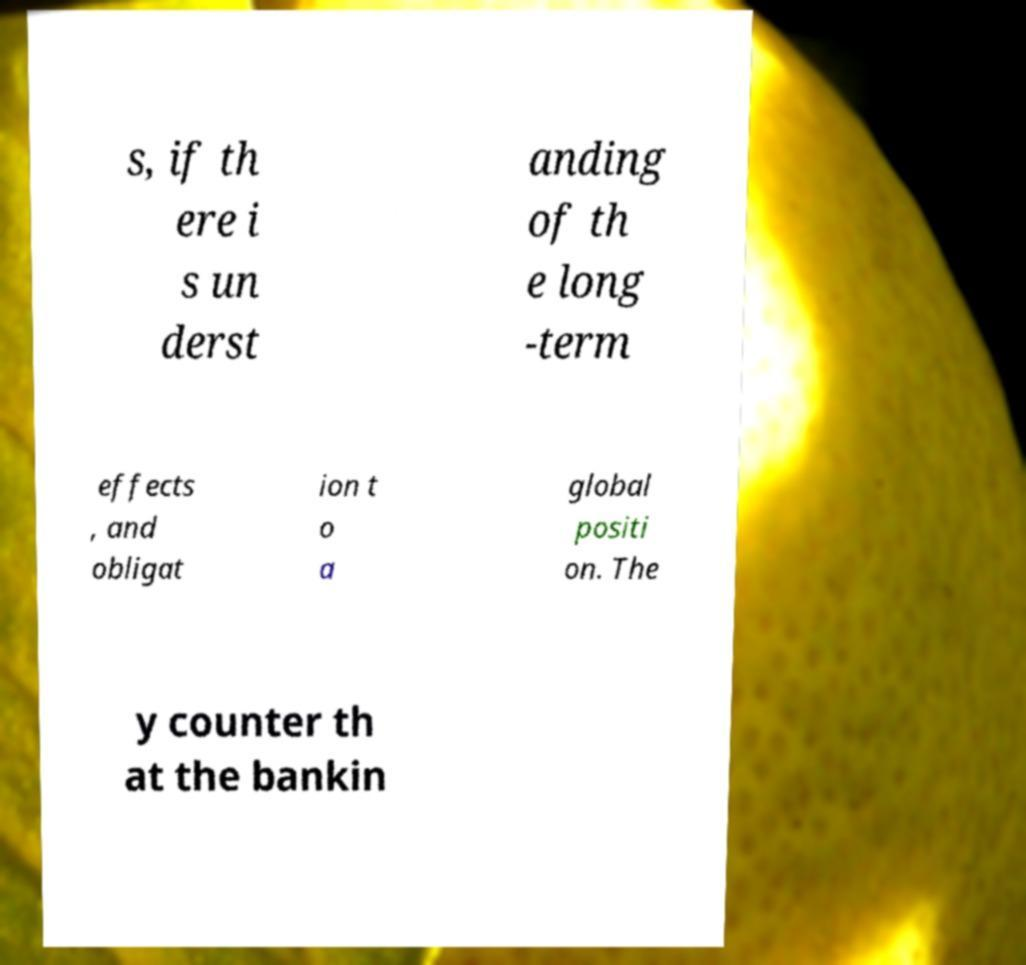There's text embedded in this image that I need extracted. Can you transcribe it verbatim? s, if th ere i s un derst anding of th e long -term effects , and obligat ion t o a global positi on. The y counter th at the bankin 